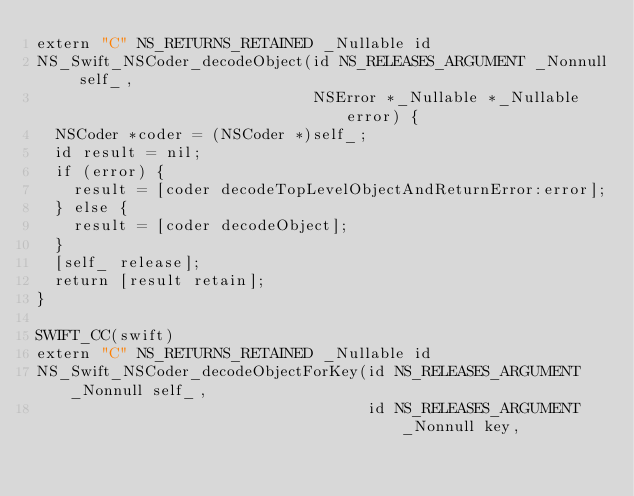Convert code to text. <code><loc_0><loc_0><loc_500><loc_500><_ObjectiveC_>extern "C" NS_RETURNS_RETAINED _Nullable id
NS_Swift_NSCoder_decodeObject(id NS_RELEASES_ARGUMENT _Nonnull self_,
                              NSError *_Nullable *_Nullable error) {
  NSCoder *coder = (NSCoder *)self_;
  id result = nil;
  if (error) {
    result = [coder decodeTopLevelObjectAndReturnError:error];
  } else {
    result = [coder decodeObject];
  }
  [self_ release];
  return [result retain];
}

SWIFT_CC(swift)
extern "C" NS_RETURNS_RETAINED _Nullable id
NS_Swift_NSCoder_decodeObjectForKey(id NS_RELEASES_ARGUMENT _Nonnull self_,
                                    id NS_RELEASES_ARGUMENT _Nonnull key,</code> 